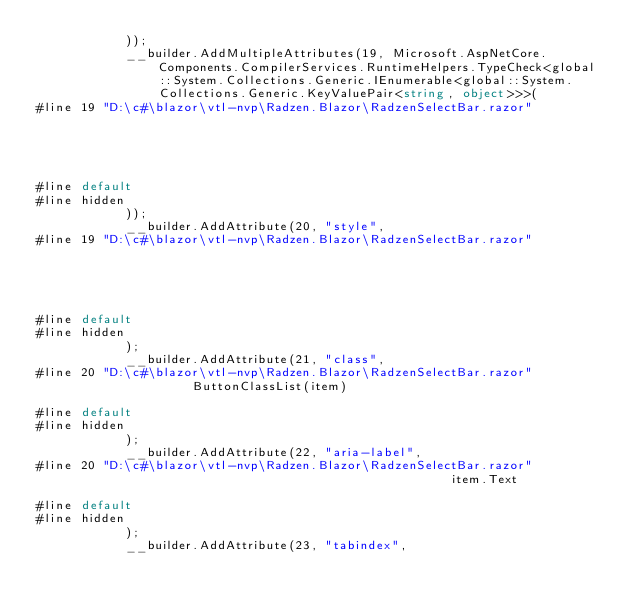Convert code to text. <code><loc_0><loc_0><loc_500><loc_500><_C#_>            ));
            __builder.AddMultipleAttributes(19, Microsoft.AspNetCore.Components.CompilerServices.RuntimeHelpers.TypeCheck<global::System.Collections.Generic.IEnumerable<global::System.Collections.Generic.KeyValuePair<string, object>>>(
#line 19 "D:\c#\blazor\vtl-nvp\Radzen.Blazor\RadzenSelectBar.razor"
                                                                                                                                                           item.Attributes

#line default
#line hidden
            ));
            __builder.AddAttribute(20, "style", 
#line 19 "D:\c#\blazor\vtl-nvp\Radzen.Blazor\RadzenSelectBar.razor"
                                                                                                                                                                                    item.Style

#line default
#line hidden
            );
            __builder.AddAttribute(21, "class", 
#line 20 "D:\c#\blazor\vtl-nvp\Radzen.Blazor\RadzenSelectBar.razor"
                     ButtonClassList(item)

#line default
#line hidden
            );
            __builder.AddAttribute(22, "aria-label", 
#line 20 "D:\c#\blazor\vtl-nvp\Radzen.Blazor\RadzenSelectBar.razor"
                                                        item.Text

#line default
#line hidden
            );
            __builder.AddAttribute(23, "tabindex", </code> 